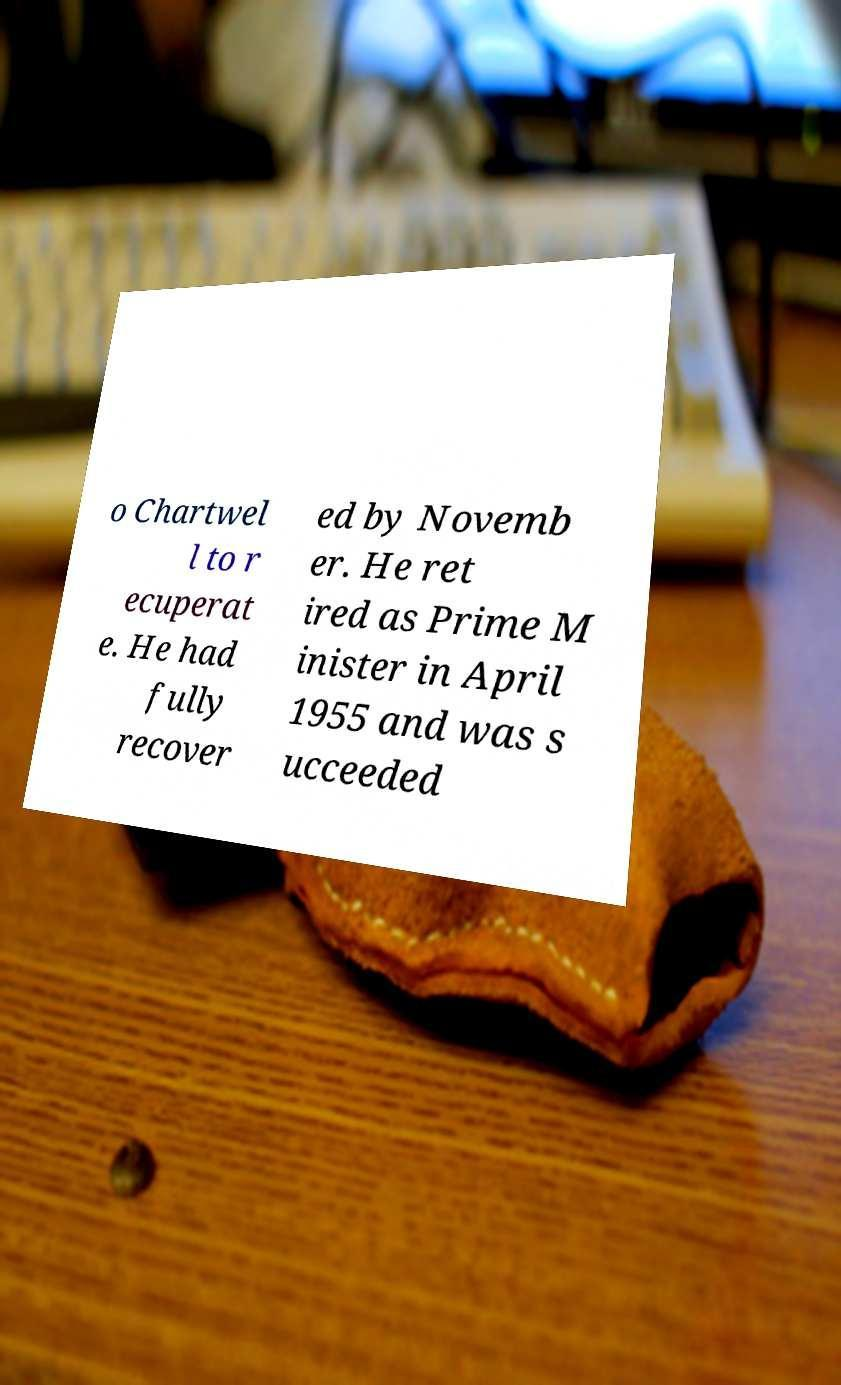I need the written content from this picture converted into text. Can you do that? o Chartwel l to r ecuperat e. He had fully recover ed by Novemb er. He ret ired as Prime M inister in April 1955 and was s ucceeded 